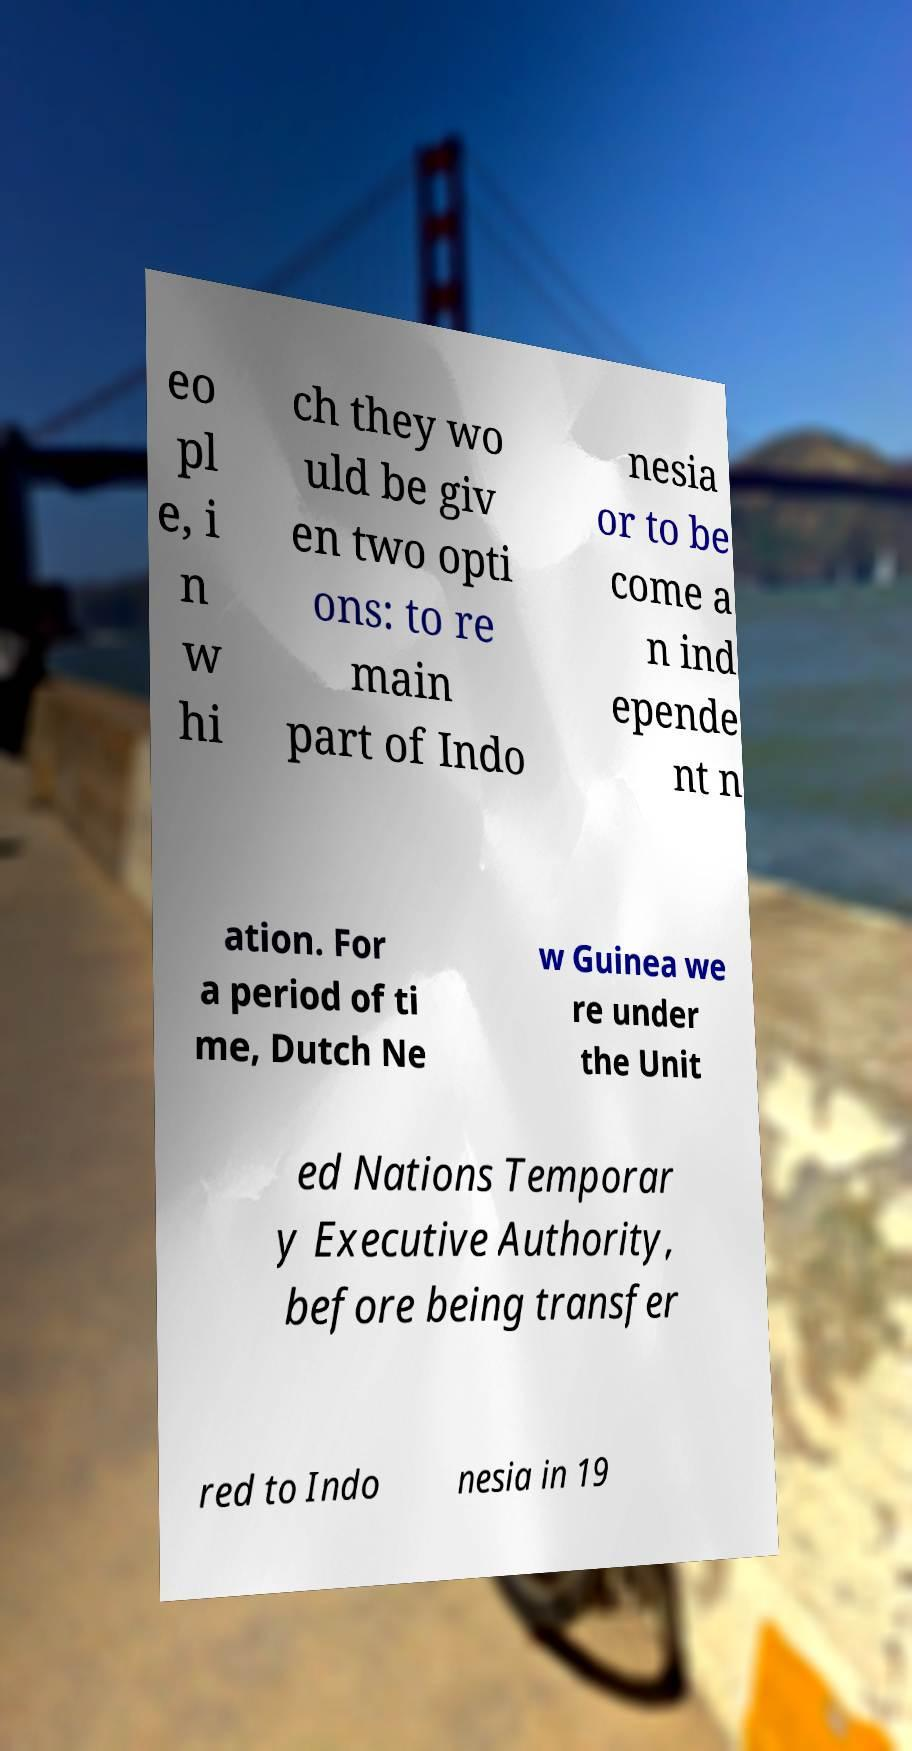Can you accurately transcribe the text from the provided image for me? eo pl e, i n w hi ch they wo uld be giv en two opti ons: to re main part of Indo nesia or to be come a n ind epende nt n ation. For a period of ti me, Dutch Ne w Guinea we re under the Unit ed Nations Temporar y Executive Authority, before being transfer red to Indo nesia in 19 